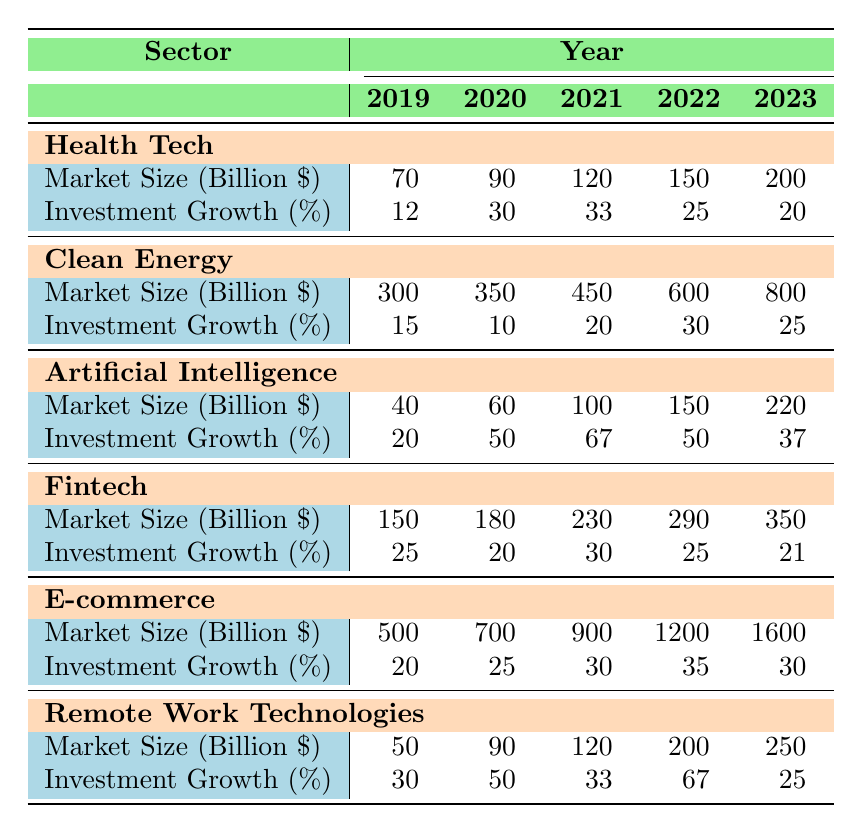What was the market size of Health Tech in 2022? According to the table, the market size of Health Tech in 2022 is listed as 150 billion dollars.
Answer: 150 billion dollars Which sector experienced the highest investment growth in 2021? Looking at the investment growth percentages for 2021, Artificial Intelligence has the highest growth at 67%.
Answer: Artificial Intelligence What is the average market size of E-commerce from 2019 to 2023? The market sizes from 2019 to 2023 for E-commerce are 500, 700, 900, 1200, and 1600 billion dollars. The sum is 500 + 700 + 900 + 1200 + 1600 = 4100. Dividing by the number of years (5), average = 4100 / 5 = 820 billion dollars.
Answer: 820 billion dollars In how many years did Clean Energy have investment growth of over 20%? The investment growth percentages for Clean Energy are 15%, 10%, 20%, 30%, and 25%. The years with growth over 20% are 2022 (30%) and 2023 (25%), totaling 2 years.
Answer: 2 years What is the total market size for Remote Work Technologies over the five years? The market sizes for Remote Work Technologies are 50, 90, 120, 200, and 250 billion dollars. Adding them gives 50 + 90 + 120 + 200 + 250 = 710 billion dollars.
Answer: 710 billion dollars Did E-commerce see a decrease in market size from 2019 to 2020? Comparing the market sizes, E-commerce was 500 billion dollars in 2019 and 700 billion dollars in 2020, which is an increase, not a decrease.
Answer: No What is the difference in market size between Artificial Intelligence and Fintech in 2023? In 2023, the market size for Artificial Intelligence is 220 billion dollars and for Fintech is 350 billion dollars. The difference is 350 - 220 = 130 billion dollars.
Answer: 130 billion dollars Which sector had the lowest investment growth in 2020? The table shows the investment growth for 2020 as 30% for Health Tech, 10% for Clean Energy, 50% for Artificial Intelligence, 20% for Fintech, 25% for E-commerce, and 50% for Remote Work Technologies. The lowest is Clean Energy at 10%.
Answer: Clean Energy What are the key players in the Health Tech sector according to the table? The key players listed for Health Tech are Teladoc Health, Amwell, and Livongo Health.
Answer: Teladoc Health, Amwell, Livongo Health How does the investment growth of Remote Work Technologies in 2022 compare to that of Fintech? The investment growth for Remote Work Technologies in 2022 is 67%, while for Fintech it is 25%. The comparison shows Remote Work Technologies had significantly higher growth.
Answer: Higher for Remote Work Technologies What was the trend in market size for Clean Energy over the five years? The market size for Clean Energy grew from 300 billion in 2019 to 800 billion in 2023, showing a steady increase over the five years.
Answer: Steady increase 